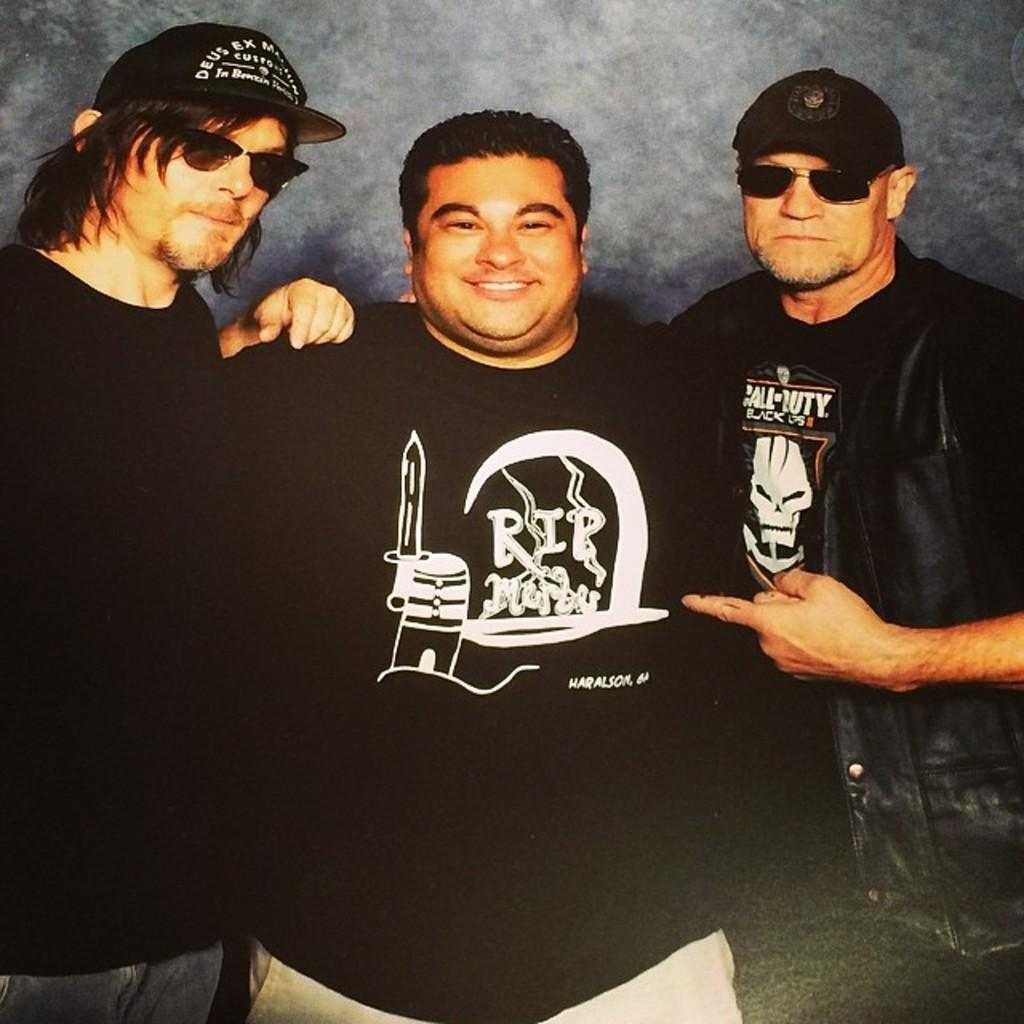How many people are in the image? There are three persons in the image. What are the people wearing? All three persons are wearing black dresses. One person is wearing a black coat, and two persons are wearing caps and goggles. Can you describe the attire of the person wearing a coat? The person wearing a coat is also wearing a black dress, and they have a black coat on top. How many people are wearing caps and goggles? Two persons are wearing caps and goggles. What type of science experiment can be seen in the image? There is no science experiment present in the image. What kind of pets are visible in the image? There are no pets visible in the image. 